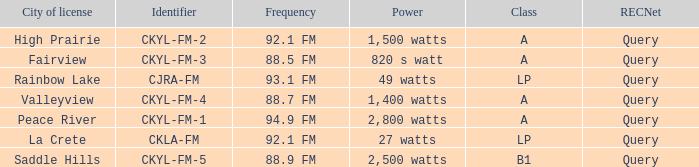What is the city of license that has a 1,400 watts power Valleyview. 